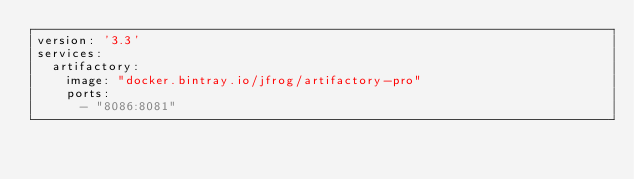Convert code to text. <code><loc_0><loc_0><loc_500><loc_500><_YAML_>version: '3.3'
services:
  artifactory:
    image: "docker.bintray.io/jfrog/artifactory-pro"
    ports:
      - "8086:8081"</code> 